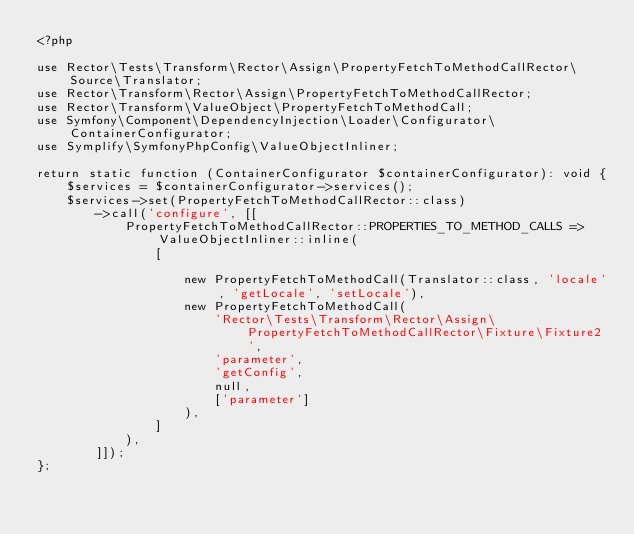<code> <loc_0><loc_0><loc_500><loc_500><_PHP_><?php

use Rector\Tests\Transform\Rector\Assign\PropertyFetchToMethodCallRector\Source\Translator;
use Rector\Transform\Rector\Assign\PropertyFetchToMethodCallRector;
use Rector\Transform\ValueObject\PropertyFetchToMethodCall;
use Symfony\Component\DependencyInjection\Loader\Configurator\ContainerConfigurator;
use Symplify\SymfonyPhpConfig\ValueObjectInliner;

return static function (ContainerConfigurator $containerConfigurator): void {
    $services = $containerConfigurator->services();
    $services->set(PropertyFetchToMethodCallRector::class)
        ->call('configure', [[
            PropertyFetchToMethodCallRector::PROPERTIES_TO_METHOD_CALLS => ValueObjectInliner::inline(
                [

                    new PropertyFetchToMethodCall(Translator::class, 'locale', 'getLocale', 'setLocale'),
                    new PropertyFetchToMethodCall(
                        'Rector\Tests\Transform\Rector\Assign\PropertyFetchToMethodCallRector\Fixture\Fixture2',
                        'parameter',
                        'getConfig',
                        null,
                        ['parameter']
                    ),
                ]
            ),
        ]]);
};
</code> 